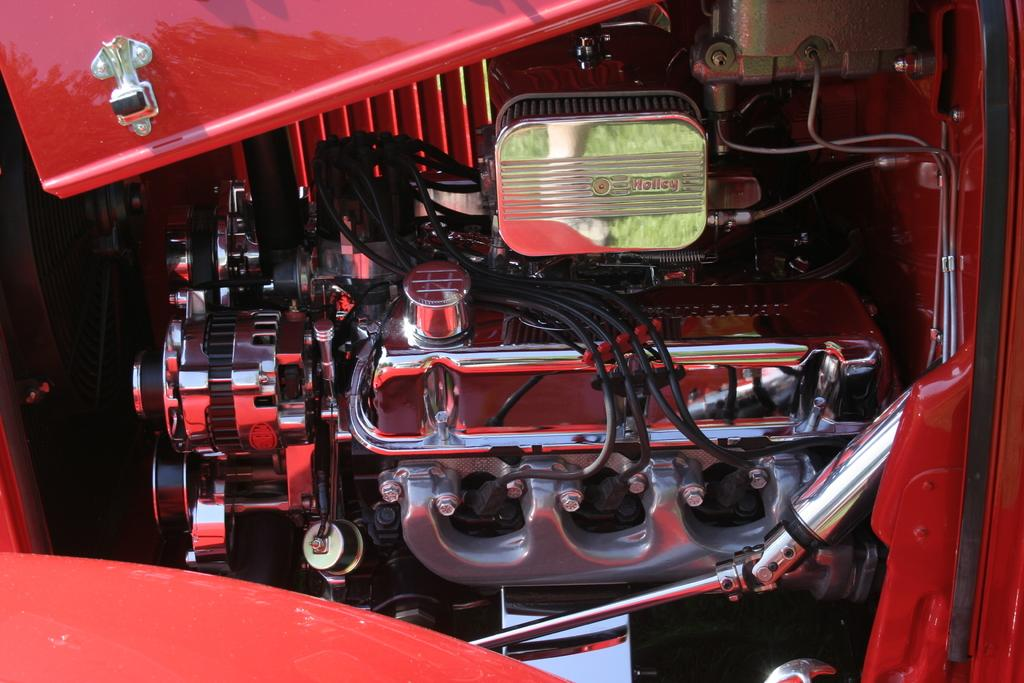What can be seen in the image that is related to electricity or communication? There are wires in the image. What is the main mechanical component visible in the image? There is an engine in the image. What other parts of a vehicle can be seen in the image? There are other parts of a vehicle in the image. Can you tell me how many straws are present in the image? There is no mention of straws in the image, so it is not possible to determine their presence or quantity. Is there a cactus visible in the image? There is no cactus present in the image. 